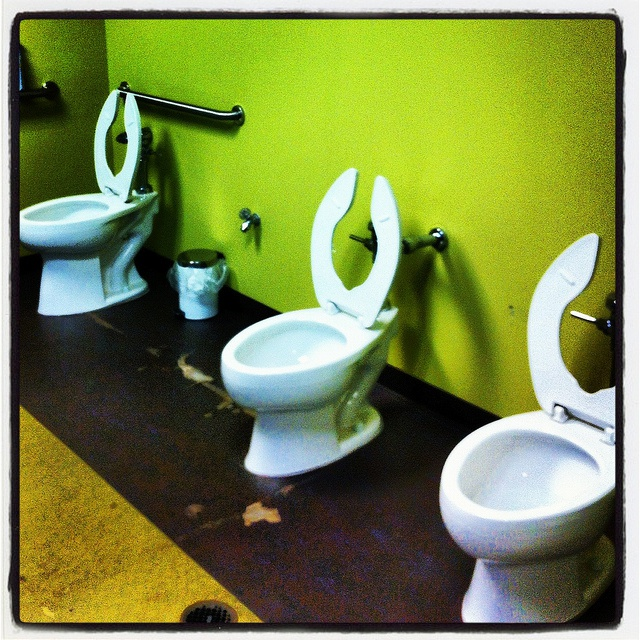Describe the objects in this image and their specific colors. I can see toilet in white, black, darkgray, and gray tones, toilet in white, lightblue, darkgreen, and teal tones, and toilet in white, lightblue, black, and teal tones in this image. 